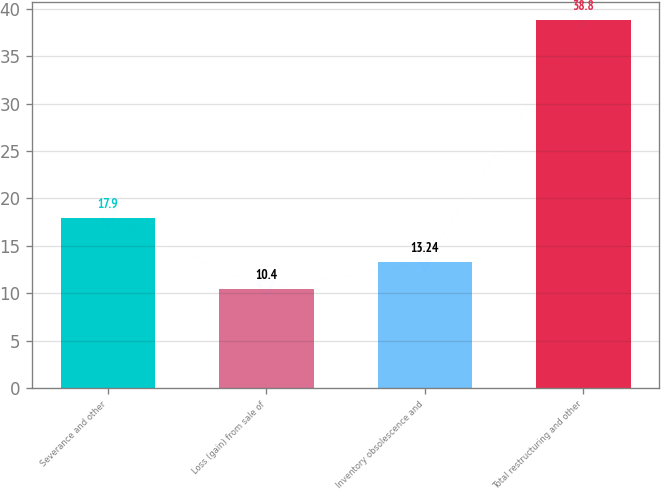<chart> <loc_0><loc_0><loc_500><loc_500><bar_chart><fcel>Severance and other<fcel>Loss (gain) from sale of<fcel>Inventory obsolescence and<fcel>Total restructuring and other<nl><fcel>17.9<fcel>10.4<fcel>13.24<fcel>38.8<nl></chart> 